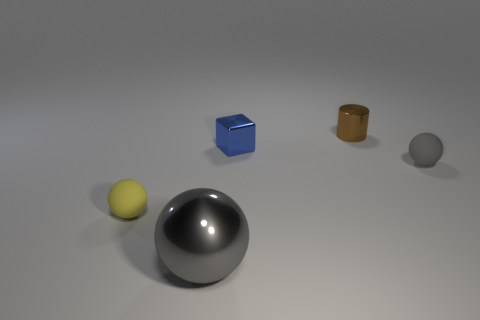Subtract all tiny rubber spheres. How many spheres are left? 1 Add 4 large blue cylinders. How many large blue cylinders exist? 4 Add 2 brown objects. How many objects exist? 7 Subtract all yellow balls. How many balls are left? 2 Subtract 0 red balls. How many objects are left? 5 Subtract all spheres. How many objects are left? 2 Subtract 2 spheres. How many spheres are left? 1 Subtract all red balls. Subtract all cyan cylinders. How many balls are left? 3 Subtract all yellow blocks. How many green balls are left? 0 Subtract all gray spheres. Subtract all blue metallic spheres. How many objects are left? 3 